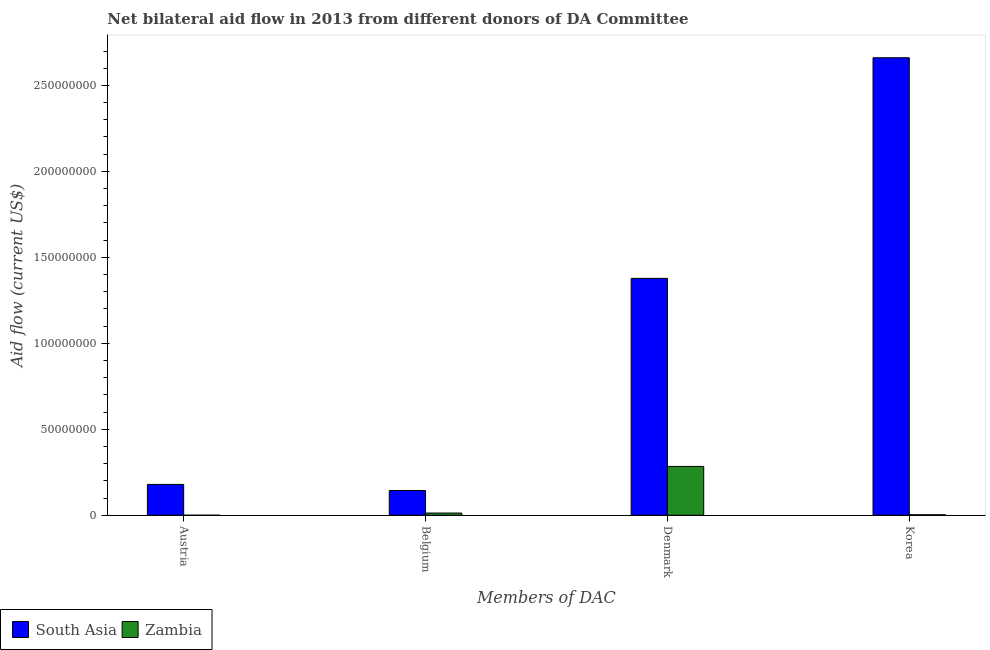How many different coloured bars are there?
Keep it short and to the point. 2. How many groups of bars are there?
Offer a terse response. 4. Are the number of bars per tick equal to the number of legend labels?
Give a very brief answer. Yes. How many bars are there on the 1st tick from the right?
Your answer should be very brief. 2. What is the amount of aid given by austria in South Asia?
Keep it short and to the point. 1.79e+07. Across all countries, what is the maximum amount of aid given by belgium?
Provide a short and direct response. 1.44e+07. Across all countries, what is the minimum amount of aid given by belgium?
Provide a short and direct response. 1.29e+06. In which country was the amount of aid given by korea maximum?
Provide a succinct answer. South Asia. In which country was the amount of aid given by denmark minimum?
Offer a very short reply. Zambia. What is the total amount of aid given by belgium in the graph?
Provide a succinct answer. 1.57e+07. What is the difference between the amount of aid given by austria in Zambia and that in South Asia?
Ensure brevity in your answer.  -1.79e+07. What is the difference between the amount of aid given by austria in South Asia and the amount of aid given by denmark in Zambia?
Provide a short and direct response. -1.04e+07. What is the average amount of aid given by denmark per country?
Ensure brevity in your answer.  8.31e+07. What is the difference between the amount of aid given by denmark and amount of aid given by korea in Zambia?
Provide a short and direct response. 2.81e+07. In how many countries, is the amount of aid given by denmark greater than 120000000 US$?
Ensure brevity in your answer.  1. What is the ratio of the amount of aid given by korea in Zambia to that in South Asia?
Provide a succinct answer. 0. Is the amount of aid given by austria in Zambia less than that in South Asia?
Offer a very short reply. Yes. Is the difference between the amount of aid given by austria in South Asia and Zambia greater than the difference between the amount of aid given by belgium in South Asia and Zambia?
Keep it short and to the point. Yes. What is the difference between the highest and the second highest amount of aid given by belgium?
Keep it short and to the point. 1.31e+07. What is the difference between the highest and the lowest amount of aid given by belgium?
Offer a very short reply. 1.31e+07. In how many countries, is the amount of aid given by denmark greater than the average amount of aid given by denmark taken over all countries?
Your answer should be very brief. 1. Is the sum of the amount of aid given by korea in Zambia and South Asia greater than the maximum amount of aid given by denmark across all countries?
Give a very brief answer. Yes. Is it the case that in every country, the sum of the amount of aid given by belgium and amount of aid given by denmark is greater than the sum of amount of aid given by austria and amount of aid given by korea?
Offer a very short reply. Yes. What does the 2nd bar from the left in Denmark represents?
Offer a very short reply. Zambia. Is it the case that in every country, the sum of the amount of aid given by austria and amount of aid given by belgium is greater than the amount of aid given by denmark?
Ensure brevity in your answer.  No. Where does the legend appear in the graph?
Provide a succinct answer. Bottom left. How are the legend labels stacked?
Your answer should be very brief. Horizontal. What is the title of the graph?
Your answer should be compact. Net bilateral aid flow in 2013 from different donors of DA Committee. What is the label or title of the X-axis?
Offer a terse response. Members of DAC. What is the label or title of the Y-axis?
Offer a very short reply. Aid flow (current US$). What is the Aid flow (current US$) in South Asia in Austria?
Provide a short and direct response. 1.79e+07. What is the Aid flow (current US$) in South Asia in Belgium?
Offer a terse response. 1.44e+07. What is the Aid flow (current US$) of Zambia in Belgium?
Your response must be concise. 1.29e+06. What is the Aid flow (current US$) of South Asia in Denmark?
Your response must be concise. 1.38e+08. What is the Aid flow (current US$) of Zambia in Denmark?
Ensure brevity in your answer.  2.84e+07. What is the Aid flow (current US$) of South Asia in Korea?
Make the answer very short. 2.66e+08. Across all Members of DAC, what is the maximum Aid flow (current US$) in South Asia?
Make the answer very short. 2.66e+08. Across all Members of DAC, what is the maximum Aid flow (current US$) of Zambia?
Provide a short and direct response. 2.84e+07. Across all Members of DAC, what is the minimum Aid flow (current US$) in South Asia?
Offer a terse response. 1.44e+07. What is the total Aid flow (current US$) in South Asia in the graph?
Your response must be concise. 4.36e+08. What is the total Aid flow (current US$) in Zambia in the graph?
Your answer should be very brief. 3.00e+07. What is the difference between the Aid flow (current US$) of South Asia in Austria and that in Belgium?
Provide a short and direct response. 3.54e+06. What is the difference between the Aid flow (current US$) in Zambia in Austria and that in Belgium?
Your answer should be very brief. -1.26e+06. What is the difference between the Aid flow (current US$) in South Asia in Austria and that in Denmark?
Provide a short and direct response. -1.20e+08. What is the difference between the Aid flow (current US$) of Zambia in Austria and that in Denmark?
Give a very brief answer. -2.84e+07. What is the difference between the Aid flow (current US$) in South Asia in Austria and that in Korea?
Ensure brevity in your answer.  -2.48e+08. What is the difference between the Aid flow (current US$) in Zambia in Austria and that in Korea?
Offer a terse response. -2.50e+05. What is the difference between the Aid flow (current US$) of South Asia in Belgium and that in Denmark?
Provide a short and direct response. -1.23e+08. What is the difference between the Aid flow (current US$) of Zambia in Belgium and that in Denmark?
Offer a very short reply. -2.71e+07. What is the difference between the Aid flow (current US$) of South Asia in Belgium and that in Korea?
Provide a short and direct response. -2.52e+08. What is the difference between the Aid flow (current US$) in Zambia in Belgium and that in Korea?
Offer a terse response. 1.01e+06. What is the difference between the Aid flow (current US$) of South Asia in Denmark and that in Korea?
Your response must be concise. -1.28e+08. What is the difference between the Aid flow (current US$) in Zambia in Denmark and that in Korea?
Give a very brief answer. 2.81e+07. What is the difference between the Aid flow (current US$) of South Asia in Austria and the Aid flow (current US$) of Zambia in Belgium?
Give a very brief answer. 1.66e+07. What is the difference between the Aid flow (current US$) of South Asia in Austria and the Aid flow (current US$) of Zambia in Denmark?
Your answer should be very brief. -1.04e+07. What is the difference between the Aid flow (current US$) in South Asia in Austria and the Aid flow (current US$) in Zambia in Korea?
Offer a very short reply. 1.77e+07. What is the difference between the Aid flow (current US$) of South Asia in Belgium and the Aid flow (current US$) of Zambia in Denmark?
Your answer should be compact. -1.40e+07. What is the difference between the Aid flow (current US$) of South Asia in Belgium and the Aid flow (current US$) of Zambia in Korea?
Provide a short and direct response. 1.41e+07. What is the difference between the Aid flow (current US$) in South Asia in Denmark and the Aid flow (current US$) in Zambia in Korea?
Provide a short and direct response. 1.37e+08. What is the average Aid flow (current US$) of South Asia per Members of DAC?
Your response must be concise. 1.09e+08. What is the average Aid flow (current US$) in Zambia per Members of DAC?
Your response must be concise. 7.50e+06. What is the difference between the Aid flow (current US$) of South Asia and Aid flow (current US$) of Zambia in Austria?
Give a very brief answer. 1.79e+07. What is the difference between the Aid flow (current US$) in South Asia and Aid flow (current US$) in Zambia in Belgium?
Your answer should be compact. 1.31e+07. What is the difference between the Aid flow (current US$) of South Asia and Aid flow (current US$) of Zambia in Denmark?
Your answer should be very brief. 1.09e+08. What is the difference between the Aid flow (current US$) of South Asia and Aid flow (current US$) of Zambia in Korea?
Provide a succinct answer. 2.66e+08. What is the ratio of the Aid flow (current US$) of South Asia in Austria to that in Belgium?
Ensure brevity in your answer.  1.25. What is the ratio of the Aid flow (current US$) in Zambia in Austria to that in Belgium?
Your answer should be compact. 0.02. What is the ratio of the Aid flow (current US$) in South Asia in Austria to that in Denmark?
Your answer should be very brief. 0.13. What is the ratio of the Aid flow (current US$) in Zambia in Austria to that in Denmark?
Offer a very short reply. 0. What is the ratio of the Aid flow (current US$) in South Asia in Austria to that in Korea?
Provide a short and direct response. 0.07. What is the ratio of the Aid flow (current US$) of Zambia in Austria to that in Korea?
Ensure brevity in your answer.  0.11. What is the ratio of the Aid flow (current US$) of South Asia in Belgium to that in Denmark?
Ensure brevity in your answer.  0.1. What is the ratio of the Aid flow (current US$) in Zambia in Belgium to that in Denmark?
Your answer should be compact. 0.05. What is the ratio of the Aid flow (current US$) in South Asia in Belgium to that in Korea?
Ensure brevity in your answer.  0.05. What is the ratio of the Aid flow (current US$) of Zambia in Belgium to that in Korea?
Keep it short and to the point. 4.61. What is the ratio of the Aid flow (current US$) in South Asia in Denmark to that in Korea?
Provide a short and direct response. 0.52. What is the ratio of the Aid flow (current US$) of Zambia in Denmark to that in Korea?
Offer a terse response. 101.39. What is the difference between the highest and the second highest Aid flow (current US$) in South Asia?
Offer a terse response. 1.28e+08. What is the difference between the highest and the second highest Aid flow (current US$) in Zambia?
Provide a short and direct response. 2.71e+07. What is the difference between the highest and the lowest Aid flow (current US$) of South Asia?
Offer a terse response. 2.52e+08. What is the difference between the highest and the lowest Aid flow (current US$) in Zambia?
Offer a terse response. 2.84e+07. 